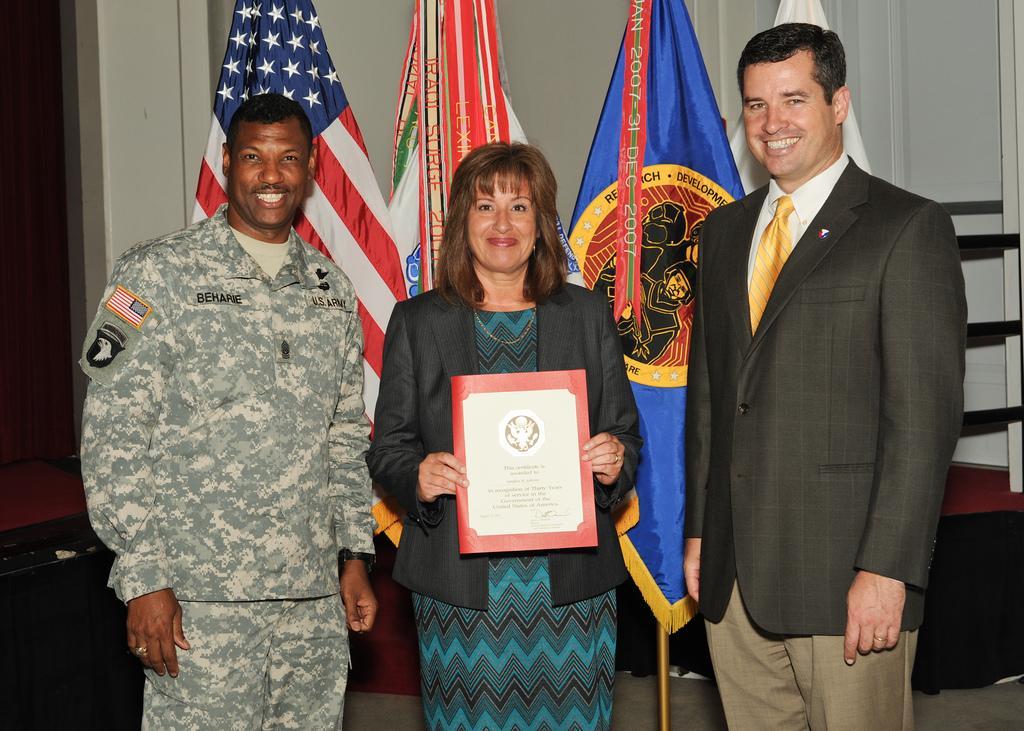In one or two sentences, can you explain what this image depicts? In this image we can see some people standing. In that a woman is holding a certificate. On the backside we can see some flags and the wall. 